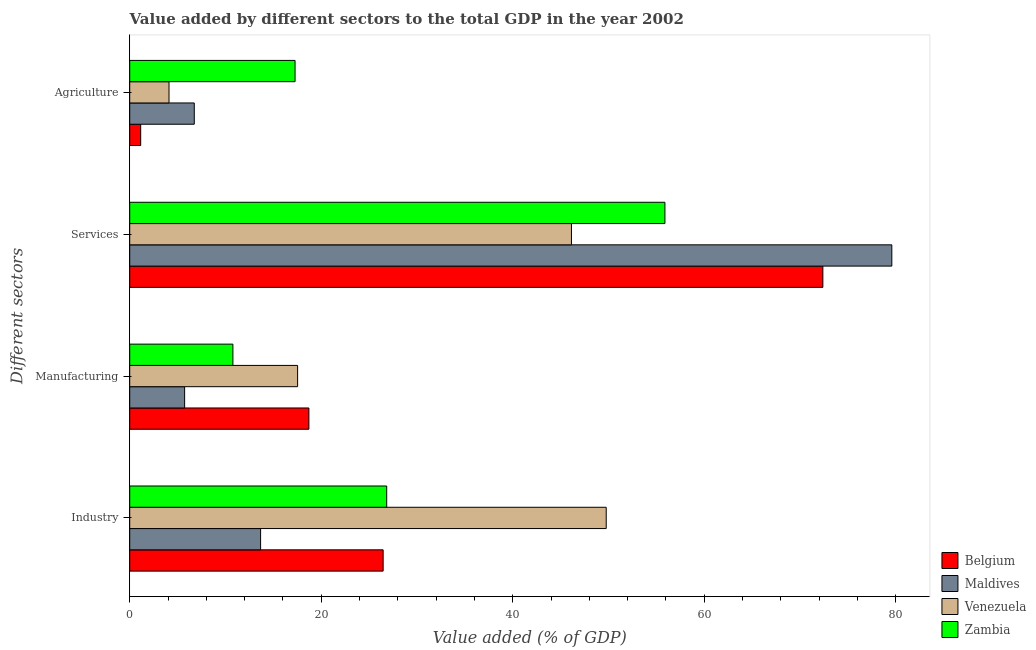How many different coloured bars are there?
Provide a short and direct response. 4. How many groups of bars are there?
Offer a very short reply. 4. Are the number of bars on each tick of the Y-axis equal?
Make the answer very short. Yes. How many bars are there on the 1st tick from the bottom?
Your answer should be compact. 4. What is the label of the 2nd group of bars from the top?
Your response must be concise. Services. What is the value added by agricultural sector in Belgium?
Your answer should be compact. 1.15. Across all countries, what is the maximum value added by industrial sector?
Offer a very short reply. 49.76. Across all countries, what is the minimum value added by industrial sector?
Offer a terse response. 13.67. In which country was the value added by industrial sector maximum?
Make the answer very short. Venezuela. In which country was the value added by services sector minimum?
Give a very brief answer. Venezuela. What is the total value added by services sector in the graph?
Offer a terse response. 254.01. What is the difference between the value added by agricultural sector in Belgium and that in Maldives?
Provide a short and direct response. -5.6. What is the difference between the value added by agricultural sector in Venezuela and the value added by manufacturing sector in Belgium?
Provide a succinct answer. -14.61. What is the average value added by industrial sector per country?
Your response must be concise. 29.18. What is the difference between the value added by industrial sector and value added by agricultural sector in Zambia?
Your answer should be very brief. 9.57. In how many countries, is the value added by services sector greater than 76 %?
Ensure brevity in your answer.  1. What is the ratio of the value added by manufacturing sector in Maldives to that in Zambia?
Your response must be concise. 0.53. Is the value added by industrial sector in Zambia less than that in Maldives?
Ensure brevity in your answer.  No. Is the difference between the value added by industrial sector in Venezuela and Zambia greater than the difference between the value added by agricultural sector in Venezuela and Zambia?
Your answer should be very brief. Yes. What is the difference between the highest and the second highest value added by manufacturing sector?
Your response must be concise. 1.18. What is the difference between the highest and the lowest value added by services sector?
Your answer should be very brief. 33.46. In how many countries, is the value added by agricultural sector greater than the average value added by agricultural sector taken over all countries?
Your response must be concise. 1. Is it the case that in every country, the sum of the value added by agricultural sector and value added by industrial sector is greater than the sum of value added by manufacturing sector and value added by services sector?
Your answer should be very brief. No. What does the 1st bar from the top in Agriculture represents?
Offer a very short reply. Zambia. What does the 2nd bar from the bottom in Industry represents?
Give a very brief answer. Maldives. How many bars are there?
Ensure brevity in your answer.  16. Are all the bars in the graph horizontal?
Provide a short and direct response. Yes. How many countries are there in the graph?
Keep it short and to the point. 4. Are the values on the major ticks of X-axis written in scientific E-notation?
Provide a short and direct response. No. Does the graph contain any zero values?
Offer a terse response. No. Where does the legend appear in the graph?
Provide a succinct answer. Bottom right. How are the legend labels stacked?
Offer a terse response. Vertical. What is the title of the graph?
Give a very brief answer. Value added by different sectors to the total GDP in the year 2002. What is the label or title of the X-axis?
Your response must be concise. Value added (% of GDP). What is the label or title of the Y-axis?
Give a very brief answer. Different sectors. What is the Value added (% of GDP) of Belgium in Industry?
Give a very brief answer. 26.47. What is the Value added (% of GDP) in Maldives in Industry?
Give a very brief answer. 13.67. What is the Value added (% of GDP) of Venezuela in Industry?
Make the answer very short. 49.76. What is the Value added (% of GDP) of Zambia in Industry?
Your answer should be compact. 26.84. What is the Value added (% of GDP) of Belgium in Manufacturing?
Keep it short and to the point. 18.71. What is the Value added (% of GDP) of Maldives in Manufacturing?
Offer a very short reply. 5.73. What is the Value added (% of GDP) of Venezuela in Manufacturing?
Provide a succinct answer. 17.53. What is the Value added (% of GDP) in Zambia in Manufacturing?
Give a very brief answer. 10.78. What is the Value added (% of GDP) of Belgium in Services?
Provide a short and direct response. 72.39. What is the Value added (% of GDP) of Maldives in Services?
Your response must be concise. 79.59. What is the Value added (% of GDP) in Venezuela in Services?
Make the answer very short. 46.13. What is the Value added (% of GDP) in Zambia in Services?
Your answer should be compact. 55.89. What is the Value added (% of GDP) in Belgium in Agriculture?
Your response must be concise. 1.15. What is the Value added (% of GDP) of Maldives in Agriculture?
Make the answer very short. 6.74. What is the Value added (% of GDP) of Venezuela in Agriculture?
Provide a short and direct response. 4.1. What is the Value added (% of GDP) in Zambia in Agriculture?
Your answer should be compact. 17.27. Across all Different sectors, what is the maximum Value added (% of GDP) of Belgium?
Your answer should be very brief. 72.39. Across all Different sectors, what is the maximum Value added (% of GDP) of Maldives?
Give a very brief answer. 79.59. Across all Different sectors, what is the maximum Value added (% of GDP) of Venezuela?
Provide a succinct answer. 49.76. Across all Different sectors, what is the maximum Value added (% of GDP) in Zambia?
Ensure brevity in your answer.  55.89. Across all Different sectors, what is the minimum Value added (% of GDP) of Belgium?
Give a very brief answer. 1.15. Across all Different sectors, what is the minimum Value added (% of GDP) in Maldives?
Provide a short and direct response. 5.73. Across all Different sectors, what is the minimum Value added (% of GDP) in Venezuela?
Give a very brief answer. 4.1. Across all Different sectors, what is the minimum Value added (% of GDP) of Zambia?
Your answer should be very brief. 10.78. What is the total Value added (% of GDP) in Belgium in the graph?
Your answer should be very brief. 118.71. What is the total Value added (% of GDP) of Maldives in the graph?
Your response must be concise. 105.73. What is the total Value added (% of GDP) of Venezuela in the graph?
Make the answer very short. 117.53. What is the total Value added (% of GDP) in Zambia in the graph?
Offer a terse response. 110.78. What is the difference between the Value added (% of GDP) of Belgium in Industry and that in Manufacturing?
Offer a terse response. 7.75. What is the difference between the Value added (% of GDP) in Maldives in Industry and that in Manufacturing?
Your answer should be compact. 7.93. What is the difference between the Value added (% of GDP) of Venezuela in Industry and that in Manufacturing?
Provide a short and direct response. 32.23. What is the difference between the Value added (% of GDP) of Zambia in Industry and that in Manufacturing?
Ensure brevity in your answer.  16.06. What is the difference between the Value added (% of GDP) of Belgium in Industry and that in Services?
Provide a succinct answer. -45.92. What is the difference between the Value added (% of GDP) in Maldives in Industry and that in Services?
Your answer should be compact. -65.92. What is the difference between the Value added (% of GDP) in Venezuela in Industry and that in Services?
Give a very brief answer. 3.63. What is the difference between the Value added (% of GDP) in Zambia in Industry and that in Services?
Your answer should be very brief. -29.06. What is the difference between the Value added (% of GDP) in Belgium in Industry and that in Agriculture?
Provide a succinct answer. 25.32. What is the difference between the Value added (% of GDP) of Maldives in Industry and that in Agriculture?
Ensure brevity in your answer.  6.93. What is the difference between the Value added (% of GDP) of Venezuela in Industry and that in Agriculture?
Provide a short and direct response. 45.66. What is the difference between the Value added (% of GDP) in Zambia in Industry and that in Agriculture?
Provide a succinct answer. 9.57. What is the difference between the Value added (% of GDP) in Belgium in Manufacturing and that in Services?
Make the answer very short. -53.68. What is the difference between the Value added (% of GDP) in Maldives in Manufacturing and that in Services?
Your response must be concise. -73.86. What is the difference between the Value added (% of GDP) of Venezuela in Manufacturing and that in Services?
Offer a terse response. -28.6. What is the difference between the Value added (% of GDP) in Zambia in Manufacturing and that in Services?
Provide a succinct answer. -45.12. What is the difference between the Value added (% of GDP) in Belgium in Manufacturing and that in Agriculture?
Provide a short and direct response. 17.57. What is the difference between the Value added (% of GDP) in Maldives in Manufacturing and that in Agriculture?
Offer a very short reply. -1.01. What is the difference between the Value added (% of GDP) in Venezuela in Manufacturing and that in Agriculture?
Your answer should be compact. 13.43. What is the difference between the Value added (% of GDP) in Zambia in Manufacturing and that in Agriculture?
Offer a very short reply. -6.49. What is the difference between the Value added (% of GDP) in Belgium in Services and that in Agriculture?
Your response must be concise. 71.24. What is the difference between the Value added (% of GDP) of Maldives in Services and that in Agriculture?
Your response must be concise. 72.85. What is the difference between the Value added (% of GDP) in Venezuela in Services and that in Agriculture?
Give a very brief answer. 42.03. What is the difference between the Value added (% of GDP) of Zambia in Services and that in Agriculture?
Your answer should be compact. 38.63. What is the difference between the Value added (% of GDP) of Belgium in Industry and the Value added (% of GDP) of Maldives in Manufacturing?
Provide a short and direct response. 20.73. What is the difference between the Value added (% of GDP) in Belgium in Industry and the Value added (% of GDP) in Venezuela in Manufacturing?
Offer a terse response. 8.93. What is the difference between the Value added (% of GDP) of Belgium in Industry and the Value added (% of GDP) of Zambia in Manufacturing?
Ensure brevity in your answer.  15.69. What is the difference between the Value added (% of GDP) of Maldives in Industry and the Value added (% of GDP) of Venezuela in Manufacturing?
Make the answer very short. -3.87. What is the difference between the Value added (% of GDP) of Maldives in Industry and the Value added (% of GDP) of Zambia in Manufacturing?
Offer a very short reply. 2.89. What is the difference between the Value added (% of GDP) in Venezuela in Industry and the Value added (% of GDP) in Zambia in Manufacturing?
Keep it short and to the point. 38.99. What is the difference between the Value added (% of GDP) in Belgium in Industry and the Value added (% of GDP) in Maldives in Services?
Keep it short and to the point. -53.13. What is the difference between the Value added (% of GDP) of Belgium in Industry and the Value added (% of GDP) of Venezuela in Services?
Your answer should be very brief. -19.67. What is the difference between the Value added (% of GDP) of Belgium in Industry and the Value added (% of GDP) of Zambia in Services?
Make the answer very short. -29.43. What is the difference between the Value added (% of GDP) of Maldives in Industry and the Value added (% of GDP) of Venezuela in Services?
Offer a very short reply. -32.47. What is the difference between the Value added (% of GDP) in Maldives in Industry and the Value added (% of GDP) in Zambia in Services?
Provide a short and direct response. -42.23. What is the difference between the Value added (% of GDP) in Venezuela in Industry and the Value added (% of GDP) in Zambia in Services?
Offer a very short reply. -6.13. What is the difference between the Value added (% of GDP) of Belgium in Industry and the Value added (% of GDP) of Maldives in Agriculture?
Offer a terse response. 19.72. What is the difference between the Value added (% of GDP) in Belgium in Industry and the Value added (% of GDP) in Venezuela in Agriculture?
Provide a short and direct response. 22.36. What is the difference between the Value added (% of GDP) in Belgium in Industry and the Value added (% of GDP) in Zambia in Agriculture?
Ensure brevity in your answer.  9.2. What is the difference between the Value added (% of GDP) of Maldives in Industry and the Value added (% of GDP) of Venezuela in Agriculture?
Your answer should be compact. 9.56. What is the difference between the Value added (% of GDP) of Maldives in Industry and the Value added (% of GDP) of Zambia in Agriculture?
Keep it short and to the point. -3.6. What is the difference between the Value added (% of GDP) of Venezuela in Industry and the Value added (% of GDP) of Zambia in Agriculture?
Your answer should be compact. 32.5. What is the difference between the Value added (% of GDP) in Belgium in Manufacturing and the Value added (% of GDP) in Maldives in Services?
Ensure brevity in your answer.  -60.88. What is the difference between the Value added (% of GDP) in Belgium in Manufacturing and the Value added (% of GDP) in Venezuela in Services?
Give a very brief answer. -27.42. What is the difference between the Value added (% of GDP) in Belgium in Manufacturing and the Value added (% of GDP) in Zambia in Services?
Make the answer very short. -37.18. What is the difference between the Value added (% of GDP) in Maldives in Manufacturing and the Value added (% of GDP) in Venezuela in Services?
Your answer should be compact. -40.4. What is the difference between the Value added (% of GDP) in Maldives in Manufacturing and the Value added (% of GDP) in Zambia in Services?
Offer a terse response. -50.16. What is the difference between the Value added (% of GDP) of Venezuela in Manufacturing and the Value added (% of GDP) of Zambia in Services?
Your answer should be compact. -38.36. What is the difference between the Value added (% of GDP) in Belgium in Manufacturing and the Value added (% of GDP) in Maldives in Agriculture?
Provide a succinct answer. 11.97. What is the difference between the Value added (% of GDP) of Belgium in Manufacturing and the Value added (% of GDP) of Venezuela in Agriculture?
Offer a very short reply. 14.61. What is the difference between the Value added (% of GDP) of Belgium in Manufacturing and the Value added (% of GDP) of Zambia in Agriculture?
Give a very brief answer. 1.44. What is the difference between the Value added (% of GDP) of Maldives in Manufacturing and the Value added (% of GDP) of Venezuela in Agriculture?
Give a very brief answer. 1.63. What is the difference between the Value added (% of GDP) in Maldives in Manufacturing and the Value added (% of GDP) in Zambia in Agriculture?
Your response must be concise. -11.53. What is the difference between the Value added (% of GDP) of Venezuela in Manufacturing and the Value added (% of GDP) of Zambia in Agriculture?
Offer a terse response. 0.27. What is the difference between the Value added (% of GDP) in Belgium in Services and the Value added (% of GDP) in Maldives in Agriculture?
Your answer should be compact. 65.65. What is the difference between the Value added (% of GDP) of Belgium in Services and the Value added (% of GDP) of Venezuela in Agriculture?
Offer a terse response. 68.29. What is the difference between the Value added (% of GDP) in Belgium in Services and the Value added (% of GDP) in Zambia in Agriculture?
Provide a succinct answer. 55.12. What is the difference between the Value added (% of GDP) in Maldives in Services and the Value added (% of GDP) in Venezuela in Agriculture?
Provide a short and direct response. 75.49. What is the difference between the Value added (% of GDP) in Maldives in Services and the Value added (% of GDP) in Zambia in Agriculture?
Offer a terse response. 62.32. What is the difference between the Value added (% of GDP) of Venezuela in Services and the Value added (% of GDP) of Zambia in Agriculture?
Make the answer very short. 28.87. What is the average Value added (% of GDP) of Belgium per Different sectors?
Keep it short and to the point. 29.68. What is the average Value added (% of GDP) of Maldives per Different sectors?
Your response must be concise. 26.43. What is the average Value added (% of GDP) of Venezuela per Different sectors?
Your response must be concise. 29.38. What is the average Value added (% of GDP) of Zambia per Different sectors?
Keep it short and to the point. 27.69. What is the difference between the Value added (% of GDP) in Belgium and Value added (% of GDP) in Maldives in Industry?
Offer a very short reply. 12.8. What is the difference between the Value added (% of GDP) in Belgium and Value added (% of GDP) in Venezuela in Industry?
Your answer should be very brief. -23.3. What is the difference between the Value added (% of GDP) of Belgium and Value added (% of GDP) of Zambia in Industry?
Provide a short and direct response. -0.37. What is the difference between the Value added (% of GDP) in Maldives and Value added (% of GDP) in Venezuela in Industry?
Ensure brevity in your answer.  -36.1. What is the difference between the Value added (% of GDP) in Maldives and Value added (% of GDP) in Zambia in Industry?
Make the answer very short. -13.17. What is the difference between the Value added (% of GDP) in Venezuela and Value added (% of GDP) in Zambia in Industry?
Your response must be concise. 22.93. What is the difference between the Value added (% of GDP) of Belgium and Value added (% of GDP) of Maldives in Manufacturing?
Keep it short and to the point. 12.98. What is the difference between the Value added (% of GDP) in Belgium and Value added (% of GDP) in Venezuela in Manufacturing?
Offer a very short reply. 1.18. What is the difference between the Value added (% of GDP) in Belgium and Value added (% of GDP) in Zambia in Manufacturing?
Keep it short and to the point. 7.94. What is the difference between the Value added (% of GDP) of Maldives and Value added (% of GDP) of Venezuela in Manufacturing?
Provide a short and direct response. -11.8. What is the difference between the Value added (% of GDP) in Maldives and Value added (% of GDP) in Zambia in Manufacturing?
Offer a very short reply. -5.04. What is the difference between the Value added (% of GDP) in Venezuela and Value added (% of GDP) in Zambia in Manufacturing?
Provide a short and direct response. 6.76. What is the difference between the Value added (% of GDP) of Belgium and Value added (% of GDP) of Maldives in Services?
Your answer should be very brief. -7.2. What is the difference between the Value added (% of GDP) in Belgium and Value added (% of GDP) in Venezuela in Services?
Make the answer very short. 26.26. What is the difference between the Value added (% of GDP) of Belgium and Value added (% of GDP) of Zambia in Services?
Make the answer very short. 16.49. What is the difference between the Value added (% of GDP) of Maldives and Value added (% of GDP) of Venezuela in Services?
Your response must be concise. 33.46. What is the difference between the Value added (% of GDP) of Maldives and Value added (% of GDP) of Zambia in Services?
Provide a succinct answer. 23.7. What is the difference between the Value added (% of GDP) of Venezuela and Value added (% of GDP) of Zambia in Services?
Your answer should be very brief. -9.76. What is the difference between the Value added (% of GDP) in Belgium and Value added (% of GDP) in Maldives in Agriculture?
Give a very brief answer. -5.6. What is the difference between the Value added (% of GDP) in Belgium and Value added (% of GDP) in Venezuela in Agriculture?
Make the answer very short. -2.96. What is the difference between the Value added (% of GDP) of Belgium and Value added (% of GDP) of Zambia in Agriculture?
Keep it short and to the point. -16.12. What is the difference between the Value added (% of GDP) of Maldives and Value added (% of GDP) of Venezuela in Agriculture?
Make the answer very short. 2.64. What is the difference between the Value added (% of GDP) of Maldives and Value added (% of GDP) of Zambia in Agriculture?
Provide a succinct answer. -10.53. What is the difference between the Value added (% of GDP) of Venezuela and Value added (% of GDP) of Zambia in Agriculture?
Ensure brevity in your answer.  -13.16. What is the ratio of the Value added (% of GDP) in Belgium in Industry to that in Manufacturing?
Your answer should be compact. 1.41. What is the ratio of the Value added (% of GDP) of Maldives in Industry to that in Manufacturing?
Keep it short and to the point. 2.38. What is the ratio of the Value added (% of GDP) of Venezuela in Industry to that in Manufacturing?
Your answer should be compact. 2.84. What is the ratio of the Value added (% of GDP) in Zambia in Industry to that in Manufacturing?
Your answer should be compact. 2.49. What is the ratio of the Value added (% of GDP) in Belgium in Industry to that in Services?
Provide a succinct answer. 0.37. What is the ratio of the Value added (% of GDP) in Maldives in Industry to that in Services?
Your answer should be compact. 0.17. What is the ratio of the Value added (% of GDP) of Venezuela in Industry to that in Services?
Give a very brief answer. 1.08. What is the ratio of the Value added (% of GDP) in Zambia in Industry to that in Services?
Your answer should be very brief. 0.48. What is the ratio of the Value added (% of GDP) in Belgium in Industry to that in Agriculture?
Provide a succinct answer. 23.11. What is the ratio of the Value added (% of GDP) of Maldives in Industry to that in Agriculture?
Provide a short and direct response. 2.03. What is the ratio of the Value added (% of GDP) of Venezuela in Industry to that in Agriculture?
Provide a short and direct response. 12.13. What is the ratio of the Value added (% of GDP) of Zambia in Industry to that in Agriculture?
Your response must be concise. 1.55. What is the ratio of the Value added (% of GDP) of Belgium in Manufacturing to that in Services?
Keep it short and to the point. 0.26. What is the ratio of the Value added (% of GDP) of Maldives in Manufacturing to that in Services?
Your answer should be very brief. 0.07. What is the ratio of the Value added (% of GDP) of Venezuela in Manufacturing to that in Services?
Your answer should be compact. 0.38. What is the ratio of the Value added (% of GDP) in Zambia in Manufacturing to that in Services?
Your answer should be compact. 0.19. What is the ratio of the Value added (% of GDP) in Belgium in Manufacturing to that in Agriculture?
Provide a succinct answer. 16.34. What is the ratio of the Value added (% of GDP) of Maldives in Manufacturing to that in Agriculture?
Provide a short and direct response. 0.85. What is the ratio of the Value added (% of GDP) in Venezuela in Manufacturing to that in Agriculture?
Provide a succinct answer. 4.27. What is the ratio of the Value added (% of GDP) of Zambia in Manufacturing to that in Agriculture?
Provide a succinct answer. 0.62. What is the ratio of the Value added (% of GDP) in Belgium in Services to that in Agriculture?
Provide a succinct answer. 63.21. What is the ratio of the Value added (% of GDP) in Maldives in Services to that in Agriculture?
Offer a very short reply. 11.81. What is the ratio of the Value added (% of GDP) in Venezuela in Services to that in Agriculture?
Your answer should be compact. 11.24. What is the ratio of the Value added (% of GDP) of Zambia in Services to that in Agriculture?
Make the answer very short. 3.24. What is the difference between the highest and the second highest Value added (% of GDP) of Belgium?
Make the answer very short. 45.92. What is the difference between the highest and the second highest Value added (% of GDP) in Maldives?
Your response must be concise. 65.92. What is the difference between the highest and the second highest Value added (% of GDP) in Venezuela?
Offer a terse response. 3.63. What is the difference between the highest and the second highest Value added (% of GDP) of Zambia?
Your response must be concise. 29.06. What is the difference between the highest and the lowest Value added (% of GDP) in Belgium?
Make the answer very short. 71.24. What is the difference between the highest and the lowest Value added (% of GDP) of Maldives?
Provide a short and direct response. 73.86. What is the difference between the highest and the lowest Value added (% of GDP) of Venezuela?
Your answer should be compact. 45.66. What is the difference between the highest and the lowest Value added (% of GDP) in Zambia?
Offer a terse response. 45.12. 